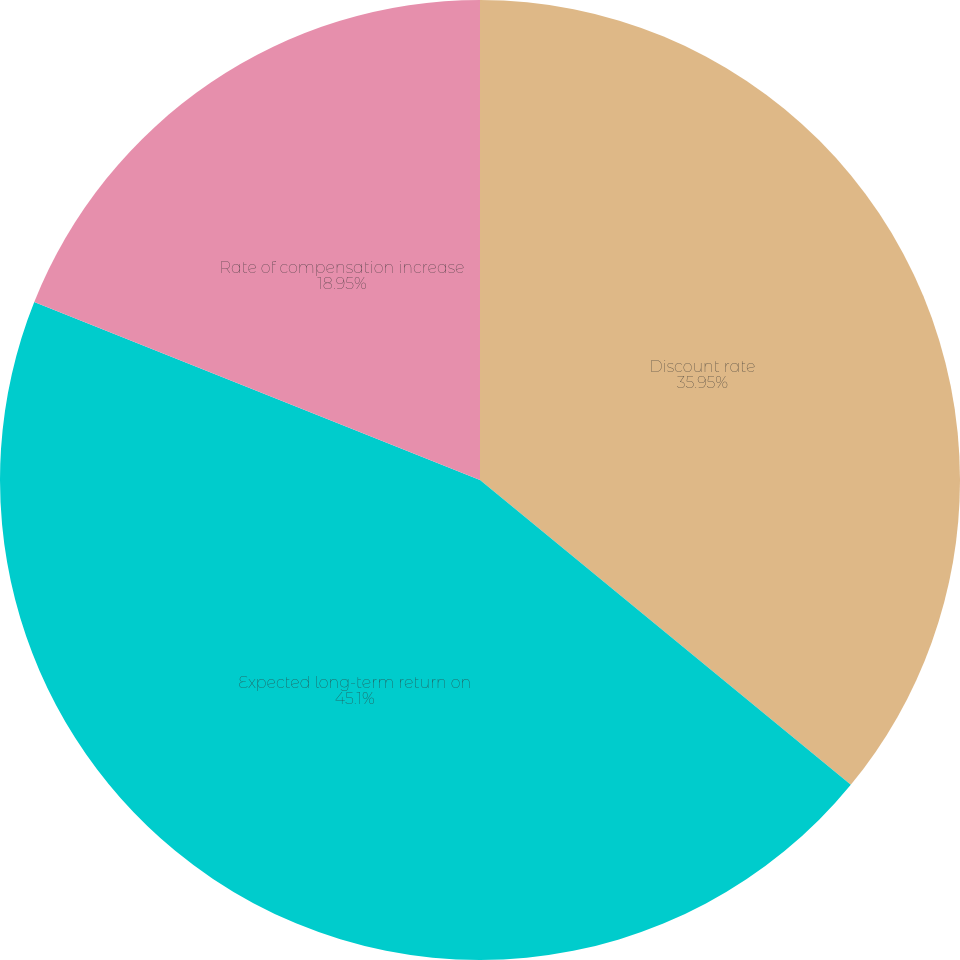<chart> <loc_0><loc_0><loc_500><loc_500><pie_chart><fcel>Discount rate<fcel>Expected long-term return on<fcel>Rate of compensation increase<nl><fcel>35.95%<fcel>45.1%<fcel>18.95%<nl></chart> 